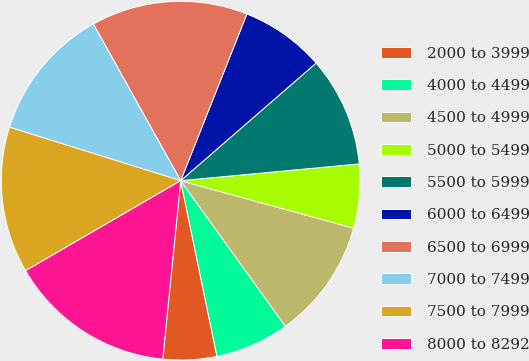<chart> <loc_0><loc_0><loc_500><loc_500><pie_chart><fcel>2000 to 3999<fcel>4000 to 4499<fcel>4500 to 4999<fcel>5000 to 5499<fcel>5500 to 5999<fcel>6000 to 6499<fcel>6500 to 6999<fcel>7000 to 7499<fcel>7500 to 7999<fcel>8000 to 8292<nl><fcel>4.84%<fcel>6.68%<fcel>10.81%<fcel>5.76%<fcel>9.89%<fcel>7.6%<fcel>14.11%<fcel>12.09%<fcel>13.19%<fcel>15.03%<nl></chart> 